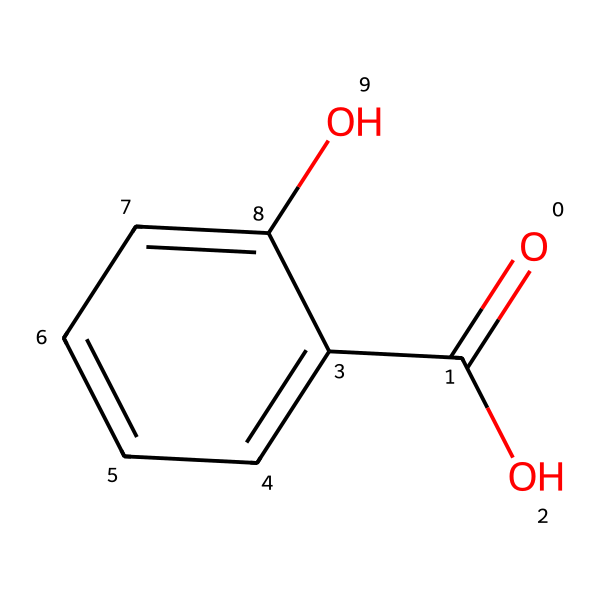What is the molecular formula of salicylic acid? To determine the molecular formula, count the number of each type of atom in the structure from the SMILES representation. In the provided SMILES, there are 7 carbon (C) atoms, 6 hydrogen (H) atoms, and 3 oxygen (O) atoms. Thus, the molecular formula is C7H6O3.
Answer: C7H6O3 How many aromatic rings are present in this structure? The structure has one aromatic ring, which can be identified by the presence of alternating double bonds and a complete set of six carbon atoms in a cyclic manner. The 'c' notation in the SMILES indicates the aromatic nature of the carbon atoms.
Answer: 1 What functional groups are present in salicylic acid? By examining the structure, we find that salicylic acid contains a carboxylic acid group (-COOH) and a hydroxyl group (-OH). The carboxylic acid is identified by the presence of the carbon doubly bonded to oxygen (C=O) and singly bonded to a hydroxyl (–OH) group.
Answer: carboxylic acid and hydroxyl Which property of salicylic acid makes it effective in treating acne? Salicylic acid is lipophilic, which allows it to penetrate oil-filled pores in the skin, helping to dissolve comedones (clogged pores) and exfoliate the skin. The chemical structure indicates it has an affinity for fats, contributing to its effectiveness as an acne treatment.
Answer: lipophilic What is the primary reason for the anti-inflammatory property of salicylic acid? The anti-inflammatory property of salicylic acid is due to the hydroxyl group (-OH) on the benzene ring. This functional group helps in reducing inflammation and redness associated with acne lesions by affecting various pathways including cytokine production.
Answer: hydroxyl group 